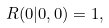<formula> <loc_0><loc_0><loc_500><loc_500>R ( 0 | 0 , 0 ) = 1 ,</formula> 